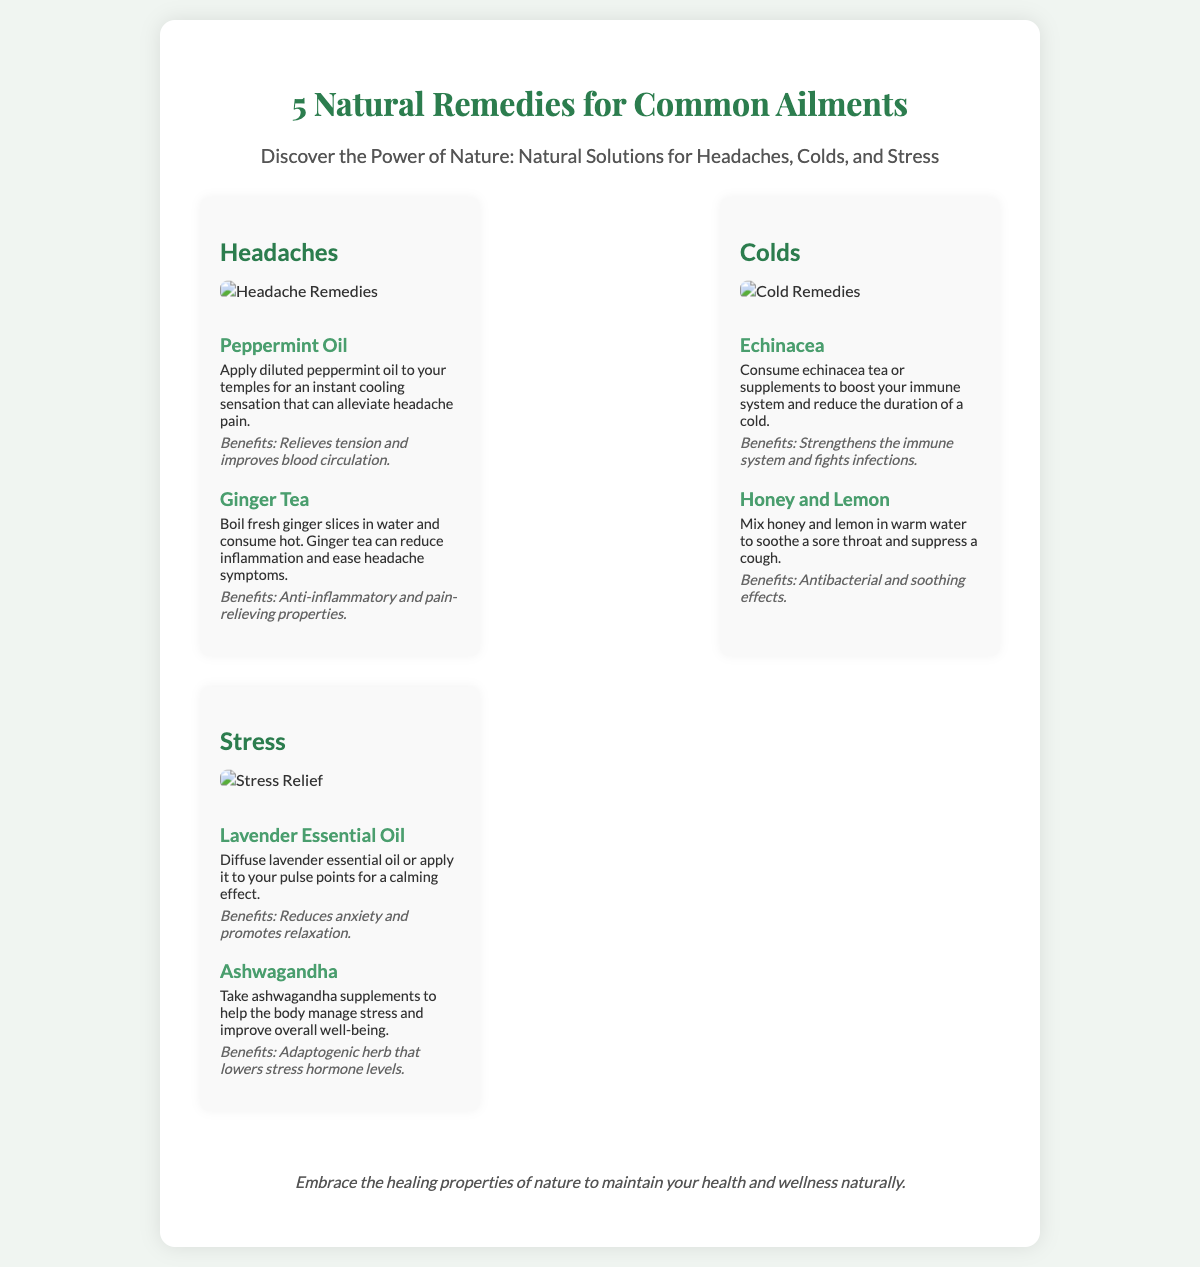What is the title of the poster? The title of the poster is prominently displayed at the top of the document indicating the main topic discussed.
Answer: 5 Natural Remedies for Common Ailments How many sections are in the poster? The poster contains three sections dedicated to different ailments, each with its remedies listed.
Answer: 3 Which essential oil is suggested for headaches? The section for headaches provides specific remedies, and one of them is an essential oil known for its effects.
Answer: Peppermint Oil What is one remedy listed for stress? The section discussing stress provides options for natural remedies, highlighting various herbal solutions.
Answer: Lavender Essential Oil What benefits are associated with ginger tea? The benefits of remedies are included after each description, giving insights into their effects on health.
Answer: Anti-inflammatory and pain-relieving properties What is a suggested remedy to boost the immune system? The poster offers remedies for colds, including specific herbs known for their immune-boosting properties.
Answer: Echinacea What two ingredients can be mixed in warm water for a sore throat? The remedies for colds recommend combining specific common ingredients for soothing effects.
Answer: Honey and Lemon What style is the header text of the poster? The font style attributed to the header is distinct, enhancing the visual appeal of the title.
Answer: Playfair Display Which herb is noted as adaptogenic? The section for stress highlights a particular herb known for its ability to help the body adapt and manage stress.
Answer: Ashwagandha 